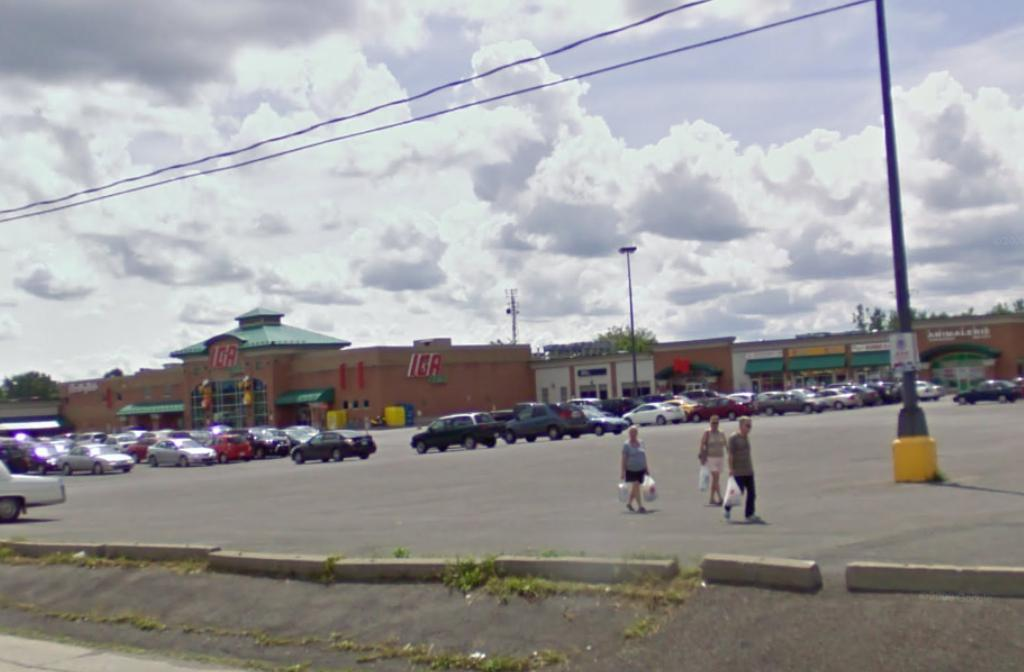<image>
Render a clear and concise summary of the photo. Several cars are parked outside a store called IGA. 